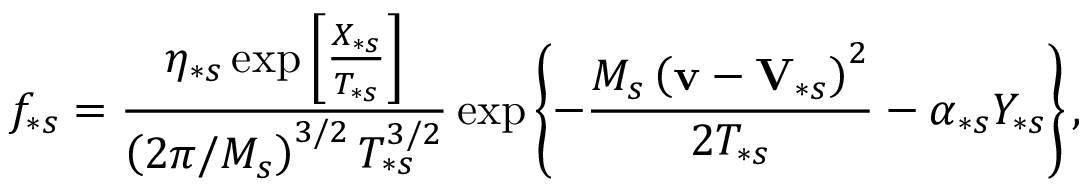Convert formula to latex. <formula><loc_0><loc_0><loc_500><loc_500>f _ { \ast s } = \frac { \eta _ { \ast s } \exp \left [ \frac { X _ { \ast s } } { T _ { \ast s } } \right ] } { \left ( 2 \pi / M _ { s } \right ) ^ { 3 / 2 } T _ { \ast s } ^ { 3 / 2 } } \exp \left \{ - \frac { M _ { s } \left ( v - V _ { \ast s } \right ) ^ { 2 } } { 2 T _ { \ast s } } - \alpha _ { \ast s } Y _ { \ast s } \right \} ,</formula> 